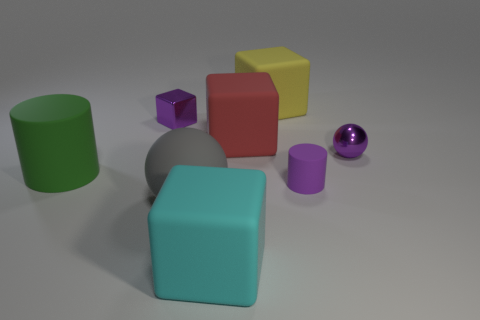Subtract 1 cubes. How many cubes are left? 3 Add 2 small yellow cubes. How many objects exist? 10 Subtract all cylinders. How many objects are left? 6 Subtract 1 purple blocks. How many objects are left? 7 Subtract all big gray spheres. Subtract all balls. How many objects are left? 5 Add 2 purple matte cylinders. How many purple matte cylinders are left? 3 Add 2 large yellow matte cubes. How many large yellow matte cubes exist? 3 